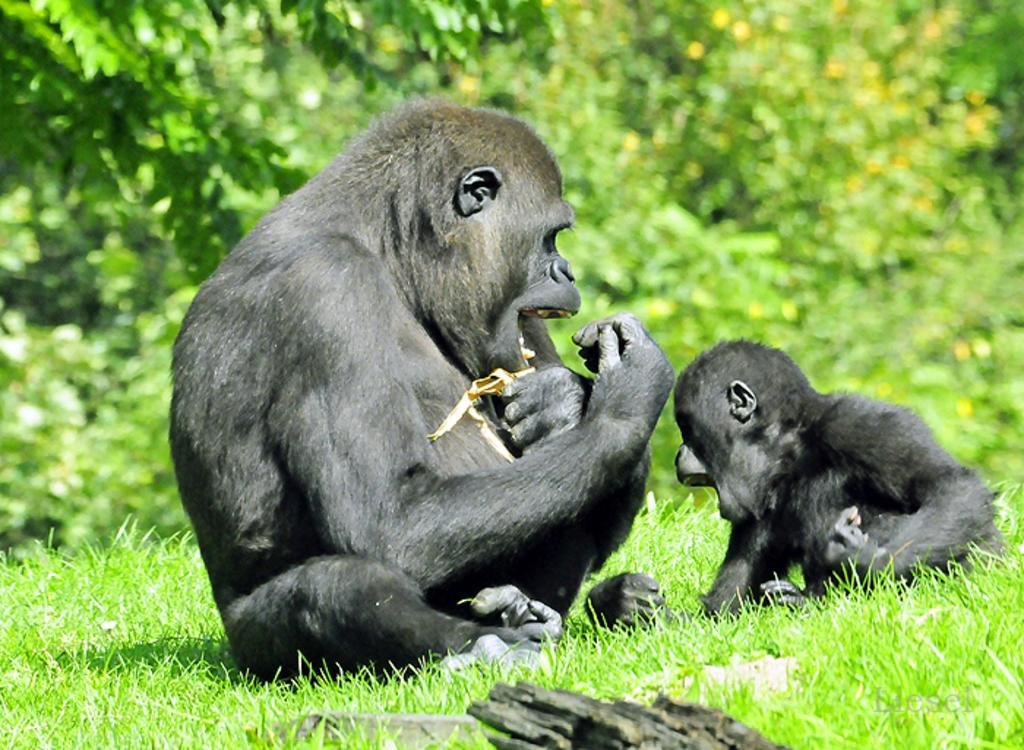What types of living organisms can be seen in the image? There are animals in the image. What is the terrain like in the image? There is grassy land in the image. What other natural elements can be seen in the image? There are many plants in the image. What type of coat is the bat wearing in the image? There is no bat present in the image, so it is not possible to determine what type of coat it might be wearing. 